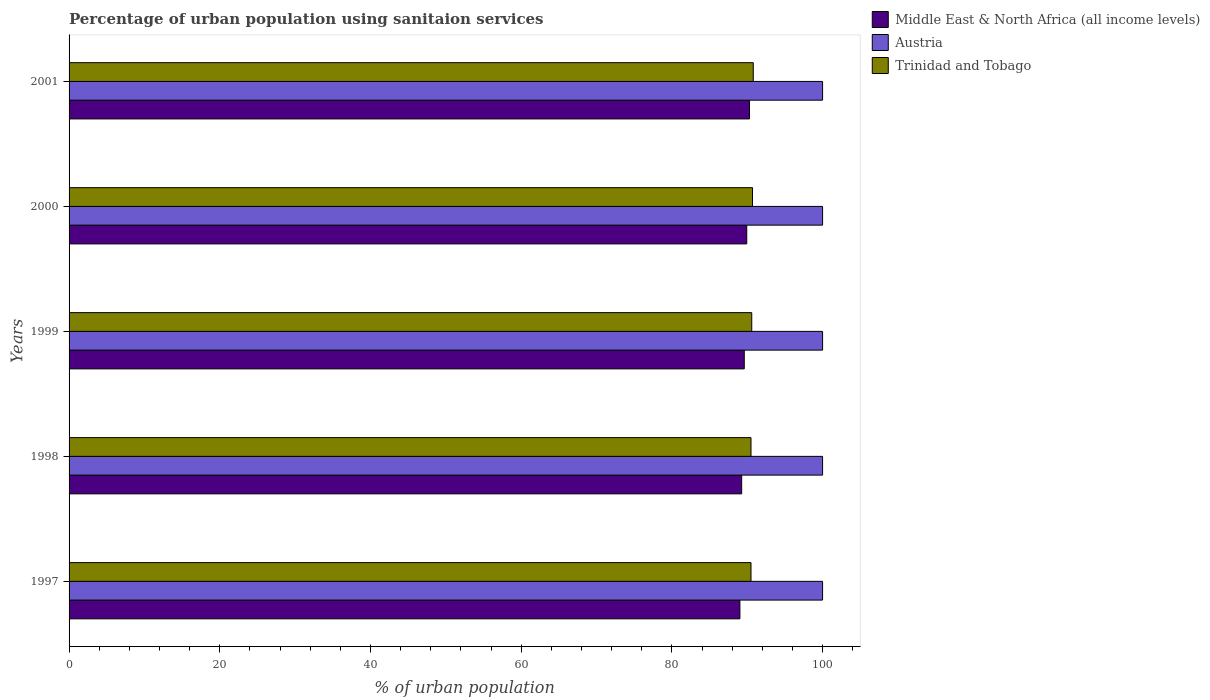How many different coloured bars are there?
Your answer should be very brief. 3. How many groups of bars are there?
Make the answer very short. 5. Are the number of bars per tick equal to the number of legend labels?
Your answer should be very brief. Yes. What is the label of the 4th group of bars from the top?
Make the answer very short. 1998. What is the percentage of urban population using sanitaion services in Trinidad and Tobago in 2001?
Keep it short and to the point. 90.8. Across all years, what is the maximum percentage of urban population using sanitaion services in Austria?
Offer a very short reply. 100. Across all years, what is the minimum percentage of urban population using sanitaion services in Trinidad and Tobago?
Ensure brevity in your answer.  90.5. In which year was the percentage of urban population using sanitaion services in Middle East & North Africa (all income levels) minimum?
Give a very brief answer. 1997. What is the total percentage of urban population using sanitaion services in Austria in the graph?
Provide a succinct answer. 500. What is the difference between the percentage of urban population using sanitaion services in Austria in 1998 and that in 2000?
Provide a succinct answer. 0. What is the difference between the percentage of urban population using sanitaion services in Austria in 1997 and the percentage of urban population using sanitaion services in Middle East & North Africa (all income levels) in 2001?
Your answer should be very brief. 9.7. What is the average percentage of urban population using sanitaion services in Trinidad and Tobago per year?
Keep it short and to the point. 90.62. In the year 1999, what is the difference between the percentage of urban population using sanitaion services in Austria and percentage of urban population using sanitaion services in Trinidad and Tobago?
Keep it short and to the point. 9.4. In how many years, is the percentage of urban population using sanitaion services in Trinidad and Tobago greater than 72 %?
Offer a very short reply. 5. What is the ratio of the percentage of urban population using sanitaion services in Middle East & North Africa (all income levels) in 1997 to that in 2000?
Provide a succinct answer. 0.99. Is the percentage of urban population using sanitaion services in Trinidad and Tobago in 1997 less than that in 1998?
Provide a succinct answer. No. Is the difference between the percentage of urban population using sanitaion services in Austria in 1998 and 2001 greater than the difference between the percentage of urban population using sanitaion services in Trinidad and Tobago in 1998 and 2001?
Provide a short and direct response. Yes. What is the difference between the highest and the second highest percentage of urban population using sanitaion services in Trinidad and Tobago?
Give a very brief answer. 0.1. What is the difference between the highest and the lowest percentage of urban population using sanitaion services in Middle East & North Africa (all income levels)?
Keep it short and to the point. 1.28. Is the sum of the percentage of urban population using sanitaion services in Middle East & North Africa (all income levels) in 1997 and 1999 greater than the maximum percentage of urban population using sanitaion services in Trinidad and Tobago across all years?
Your response must be concise. Yes. What does the 3rd bar from the bottom in 1999 represents?
Make the answer very short. Trinidad and Tobago. Is it the case that in every year, the sum of the percentage of urban population using sanitaion services in Austria and percentage of urban population using sanitaion services in Trinidad and Tobago is greater than the percentage of urban population using sanitaion services in Middle East & North Africa (all income levels)?
Your answer should be very brief. Yes. How many years are there in the graph?
Make the answer very short. 5. Does the graph contain grids?
Make the answer very short. No. How many legend labels are there?
Your answer should be very brief. 3. How are the legend labels stacked?
Make the answer very short. Vertical. What is the title of the graph?
Keep it short and to the point. Percentage of urban population using sanitaion services. Does "Senegal" appear as one of the legend labels in the graph?
Ensure brevity in your answer.  No. What is the label or title of the X-axis?
Your response must be concise. % of urban population. What is the label or title of the Y-axis?
Your answer should be compact. Years. What is the % of urban population in Middle East & North Africa (all income levels) in 1997?
Ensure brevity in your answer.  89.03. What is the % of urban population of Austria in 1997?
Your answer should be compact. 100. What is the % of urban population in Trinidad and Tobago in 1997?
Ensure brevity in your answer.  90.5. What is the % of urban population of Middle East & North Africa (all income levels) in 1998?
Offer a very short reply. 89.26. What is the % of urban population in Austria in 1998?
Offer a very short reply. 100. What is the % of urban population of Trinidad and Tobago in 1998?
Your answer should be compact. 90.5. What is the % of urban population of Middle East & North Africa (all income levels) in 1999?
Your answer should be compact. 89.61. What is the % of urban population of Austria in 1999?
Give a very brief answer. 100. What is the % of urban population in Trinidad and Tobago in 1999?
Make the answer very short. 90.6. What is the % of urban population in Middle East & North Africa (all income levels) in 2000?
Provide a succinct answer. 89.94. What is the % of urban population of Austria in 2000?
Your answer should be compact. 100. What is the % of urban population in Trinidad and Tobago in 2000?
Ensure brevity in your answer.  90.7. What is the % of urban population of Middle East & North Africa (all income levels) in 2001?
Give a very brief answer. 90.3. What is the % of urban population of Trinidad and Tobago in 2001?
Your answer should be compact. 90.8. Across all years, what is the maximum % of urban population of Middle East & North Africa (all income levels)?
Your answer should be compact. 90.3. Across all years, what is the maximum % of urban population of Trinidad and Tobago?
Give a very brief answer. 90.8. Across all years, what is the minimum % of urban population in Middle East & North Africa (all income levels)?
Your response must be concise. 89.03. Across all years, what is the minimum % of urban population in Austria?
Keep it short and to the point. 100. Across all years, what is the minimum % of urban population of Trinidad and Tobago?
Make the answer very short. 90.5. What is the total % of urban population of Middle East & North Africa (all income levels) in the graph?
Your answer should be very brief. 448.13. What is the total % of urban population of Austria in the graph?
Ensure brevity in your answer.  500. What is the total % of urban population in Trinidad and Tobago in the graph?
Offer a terse response. 453.1. What is the difference between the % of urban population in Middle East & North Africa (all income levels) in 1997 and that in 1998?
Ensure brevity in your answer.  -0.23. What is the difference between the % of urban population in Trinidad and Tobago in 1997 and that in 1998?
Make the answer very short. 0. What is the difference between the % of urban population of Middle East & North Africa (all income levels) in 1997 and that in 1999?
Your answer should be compact. -0.58. What is the difference between the % of urban population of Middle East & North Africa (all income levels) in 1997 and that in 2000?
Make the answer very short. -0.91. What is the difference between the % of urban population of Austria in 1997 and that in 2000?
Provide a succinct answer. 0. What is the difference between the % of urban population in Trinidad and Tobago in 1997 and that in 2000?
Your answer should be very brief. -0.2. What is the difference between the % of urban population of Middle East & North Africa (all income levels) in 1997 and that in 2001?
Your answer should be compact. -1.28. What is the difference between the % of urban population of Middle East & North Africa (all income levels) in 1998 and that in 1999?
Offer a very short reply. -0.34. What is the difference between the % of urban population of Austria in 1998 and that in 1999?
Your answer should be very brief. 0. What is the difference between the % of urban population of Middle East & North Africa (all income levels) in 1998 and that in 2000?
Make the answer very short. -0.68. What is the difference between the % of urban population in Trinidad and Tobago in 1998 and that in 2000?
Keep it short and to the point. -0.2. What is the difference between the % of urban population in Middle East & North Africa (all income levels) in 1998 and that in 2001?
Your answer should be very brief. -1.04. What is the difference between the % of urban population of Austria in 1998 and that in 2001?
Offer a terse response. 0. What is the difference between the % of urban population of Trinidad and Tobago in 1998 and that in 2001?
Keep it short and to the point. -0.3. What is the difference between the % of urban population of Middle East & North Africa (all income levels) in 1999 and that in 2000?
Give a very brief answer. -0.33. What is the difference between the % of urban population in Middle East & North Africa (all income levels) in 1999 and that in 2001?
Provide a succinct answer. -0.7. What is the difference between the % of urban population in Middle East & North Africa (all income levels) in 2000 and that in 2001?
Offer a very short reply. -0.37. What is the difference between the % of urban population of Middle East & North Africa (all income levels) in 1997 and the % of urban population of Austria in 1998?
Your answer should be compact. -10.97. What is the difference between the % of urban population of Middle East & North Africa (all income levels) in 1997 and the % of urban population of Trinidad and Tobago in 1998?
Ensure brevity in your answer.  -1.47. What is the difference between the % of urban population of Austria in 1997 and the % of urban population of Trinidad and Tobago in 1998?
Ensure brevity in your answer.  9.5. What is the difference between the % of urban population of Middle East & North Africa (all income levels) in 1997 and the % of urban population of Austria in 1999?
Make the answer very short. -10.97. What is the difference between the % of urban population of Middle East & North Africa (all income levels) in 1997 and the % of urban population of Trinidad and Tobago in 1999?
Give a very brief answer. -1.57. What is the difference between the % of urban population of Austria in 1997 and the % of urban population of Trinidad and Tobago in 1999?
Give a very brief answer. 9.4. What is the difference between the % of urban population in Middle East & North Africa (all income levels) in 1997 and the % of urban population in Austria in 2000?
Your answer should be compact. -10.97. What is the difference between the % of urban population in Middle East & North Africa (all income levels) in 1997 and the % of urban population in Trinidad and Tobago in 2000?
Offer a terse response. -1.67. What is the difference between the % of urban population of Austria in 1997 and the % of urban population of Trinidad and Tobago in 2000?
Provide a succinct answer. 9.3. What is the difference between the % of urban population in Middle East & North Africa (all income levels) in 1997 and the % of urban population in Austria in 2001?
Give a very brief answer. -10.97. What is the difference between the % of urban population in Middle East & North Africa (all income levels) in 1997 and the % of urban population in Trinidad and Tobago in 2001?
Keep it short and to the point. -1.77. What is the difference between the % of urban population in Middle East & North Africa (all income levels) in 1998 and the % of urban population in Austria in 1999?
Provide a succinct answer. -10.74. What is the difference between the % of urban population in Middle East & North Africa (all income levels) in 1998 and the % of urban population in Trinidad and Tobago in 1999?
Your answer should be compact. -1.34. What is the difference between the % of urban population in Austria in 1998 and the % of urban population in Trinidad and Tobago in 1999?
Offer a very short reply. 9.4. What is the difference between the % of urban population in Middle East & North Africa (all income levels) in 1998 and the % of urban population in Austria in 2000?
Offer a very short reply. -10.74. What is the difference between the % of urban population of Middle East & North Africa (all income levels) in 1998 and the % of urban population of Trinidad and Tobago in 2000?
Provide a succinct answer. -1.44. What is the difference between the % of urban population of Middle East & North Africa (all income levels) in 1998 and the % of urban population of Austria in 2001?
Give a very brief answer. -10.74. What is the difference between the % of urban population in Middle East & North Africa (all income levels) in 1998 and the % of urban population in Trinidad and Tobago in 2001?
Your answer should be compact. -1.54. What is the difference between the % of urban population of Austria in 1998 and the % of urban population of Trinidad and Tobago in 2001?
Your response must be concise. 9.2. What is the difference between the % of urban population in Middle East & North Africa (all income levels) in 1999 and the % of urban population in Austria in 2000?
Provide a short and direct response. -10.39. What is the difference between the % of urban population in Middle East & North Africa (all income levels) in 1999 and the % of urban population in Trinidad and Tobago in 2000?
Provide a short and direct response. -1.09. What is the difference between the % of urban population in Austria in 1999 and the % of urban population in Trinidad and Tobago in 2000?
Your answer should be very brief. 9.3. What is the difference between the % of urban population of Middle East & North Africa (all income levels) in 1999 and the % of urban population of Austria in 2001?
Provide a succinct answer. -10.39. What is the difference between the % of urban population of Middle East & North Africa (all income levels) in 1999 and the % of urban population of Trinidad and Tobago in 2001?
Give a very brief answer. -1.19. What is the difference between the % of urban population of Middle East & North Africa (all income levels) in 2000 and the % of urban population of Austria in 2001?
Provide a short and direct response. -10.06. What is the difference between the % of urban population of Middle East & North Africa (all income levels) in 2000 and the % of urban population of Trinidad and Tobago in 2001?
Offer a very short reply. -0.86. What is the difference between the % of urban population in Austria in 2000 and the % of urban population in Trinidad and Tobago in 2001?
Give a very brief answer. 9.2. What is the average % of urban population in Middle East & North Africa (all income levels) per year?
Keep it short and to the point. 89.63. What is the average % of urban population of Austria per year?
Offer a very short reply. 100. What is the average % of urban population of Trinidad and Tobago per year?
Offer a very short reply. 90.62. In the year 1997, what is the difference between the % of urban population of Middle East & North Africa (all income levels) and % of urban population of Austria?
Your answer should be compact. -10.97. In the year 1997, what is the difference between the % of urban population in Middle East & North Africa (all income levels) and % of urban population in Trinidad and Tobago?
Give a very brief answer. -1.47. In the year 1998, what is the difference between the % of urban population of Middle East & North Africa (all income levels) and % of urban population of Austria?
Your answer should be compact. -10.74. In the year 1998, what is the difference between the % of urban population in Middle East & North Africa (all income levels) and % of urban population in Trinidad and Tobago?
Provide a succinct answer. -1.24. In the year 1998, what is the difference between the % of urban population in Austria and % of urban population in Trinidad and Tobago?
Your response must be concise. 9.5. In the year 1999, what is the difference between the % of urban population of Middle East & North Africa (all income levels) and % of urban population of Austria?
Offer a terse response. -10.39. In the year 1999, what is the difference between the % of urban population in Middle East & North Africa (all income levels) and % of urban population in Trinidad and Tobago?
Your answer should be very brief. -0.99. In the year 2000, what is the difference between the % of urban population of Middle East & North Africa (all income levels) and % of urban population of Austria?
Make the answer very short. -10.06. In the year 2000, what is the difference between the % of urban population of Middle East & North Africa (all income levels) and % of urban population of Trinidad and Tobago?
Make the answer very short. -0.76. In the year 2001, what is the difference between the % of urban population in Middle East & North Africa (all income levels) and % of urban population in Austria?
Your answer should be compact. -9.7. In the year 2001, what is the difference between the % of urban population of Middle East & North Africa (all income levels) and % of urban population of Trinidad and Tobago?
Offer a very short reply. -0.5. What is the ratio of the % of urban population of Middle East & North Africa (all income levels) in 1997 to that in 1998?
Offer a very short reply. 1. What is the ratio of the % of urban population of Austria in 1997 to that in 1998?
Provide a short and direct response. 1. What is the ratio of the % of urban population in Trinidad and Tobago in 1997 to that in 1998?
Your response must be concise. 1. What is the ratio of the % of urban population in Middle East & North Africa (all income levels) in 1997 to that in 2000?
Offer a terse response. 0.99. What is the ratio of the % of urban population in Austria in 1997 to that in 2000?
Your answer should be very brief. 1. What is the ratio of the % of urban population in Trinidad and Tobago in 1997 to that in 2000?
Provide a succinct answer. 1. What is the ratio of the % of urban population of Middle East & North Africa (all income levels) in 1997 to that in 2001?
Keep it short and to the point. 0.99. What is the ratio of the % of urban population of Middle East & North Africa (all income levels) in 1998 to that in 1999?
Provide a short and direct response. 1. What is the ratio of the % of urban population in Austria in 1998 to that in 1999?
Offer a very short reply. 1. What is the ratio of the % of urban population in Middle East & North Africa (all income levels) in 1998 to that in 2001?
Your response must be concise. 0.99. What is the ratio of the % of urban population of Trinidad and Tobago in 1998 to that in 2001?
Provide a short and direct response. 1. What is the ratio of the % of urban population in Middle East & North Africa (all income levels) in 1999 to that in 2000?
Make the answer very short. 1. What is the ratio of the % of urban population in Trinidad and Tobago in 1999 to that in 2000?
Your answer should be very brief. 1. What is the ratio of the % of urban population of Middle East & North Africa (all income levels) in 1999 to that in 2001?
Your answer should be very brief. 0.99. What is the ratio of the % of urban population of Austria in 1999 to that in 2001?
Provide a succinct answer. 1. What is the ratio of the % of urban population in Middle East & North Africa (all income levels) in 2000 to that in 2001?
Your response must be concise. 1. What is the ratio of the % of urban population in Austria in 2000 to that in 2001?
Ensure brevity in your answer.  1. What is the difference between the highest and the second highest % of urban population of Middle East & North Africa (all income levels)?
Offer a terse response. 0.37. What is the difference between the highest and the second highest % of urban population in Trinidad and Tobago?
Your answer should be very brief. 0.1. What is the difference between the highest and the lowest % of urban population in Middle East & North Africa (all income levels)?
Your answer should be very brief. 1.28. What is the difference between the highest and the lowest % of urban population of Austria?
Give a very brief answer. 0. 